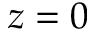<formula> <loc_0><loc_0><loc_500><loc_500>z = 0</formula> 